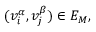<formula> <loc_0><loc_0><loc_500><loc_500>( v _ { i } ^ { \alpha } , v _ { j } ^ { \beta } ) \in E _ { M } ,</formula> 